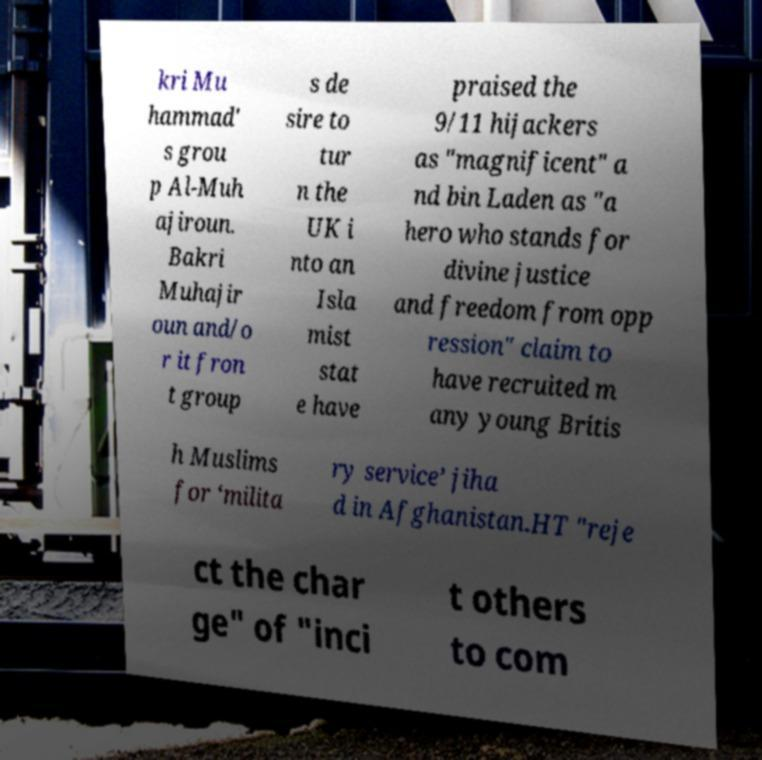Please identify and transcribe the text found in this image. kri Mu hammad' s grou p Al-Muh ajiroun. Bakri Muhajir oun and/o r it fron t group s de sire to tur n the UK i nto an Isla mist stat e have praised the 9/11 hijackers as "magnificent" a nd bin Laden as "a hero who stands for divine justice and freedom from opp ression" claim to have recruited m any young Britis h Muslims for ‘milita ry service’ jiha d in Afghanistan.HT "reje ct the char ge" of "inci t others to com 